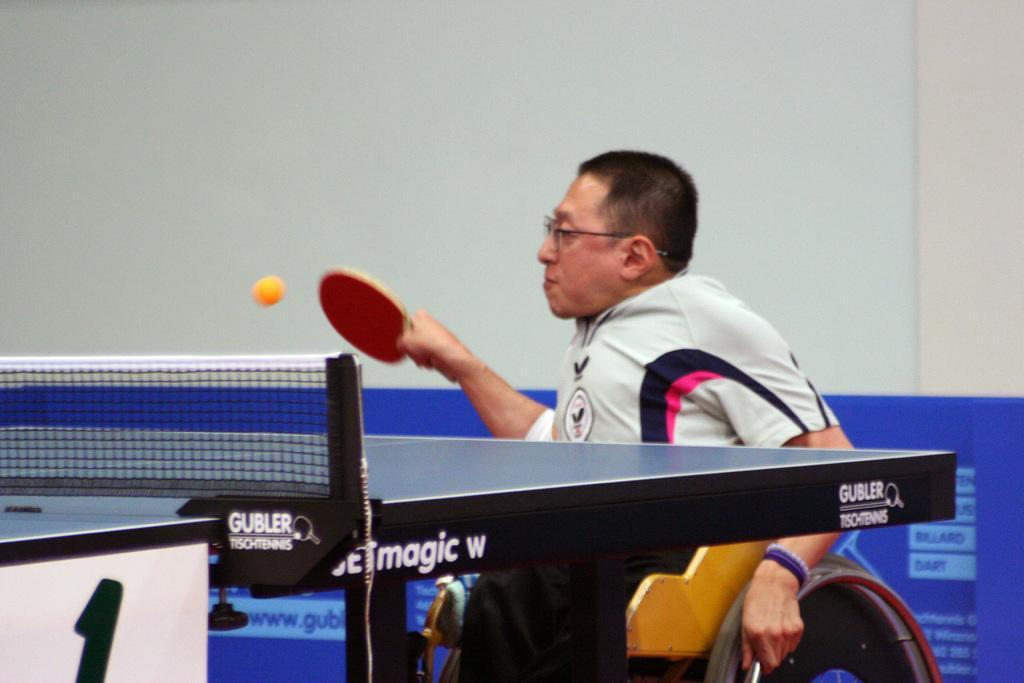How would you summarize this image in a sentence or two? There is a person wearing specs is holding a table tennis bat and sitting on a wheelchair. In front of him there is a ball and a table tennis with net. In the background there is a blue color wall with something written on it. 